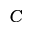Convert formula to latex. <formula><loc_0><loc_0><loc_500><loc_500>C</formula> 